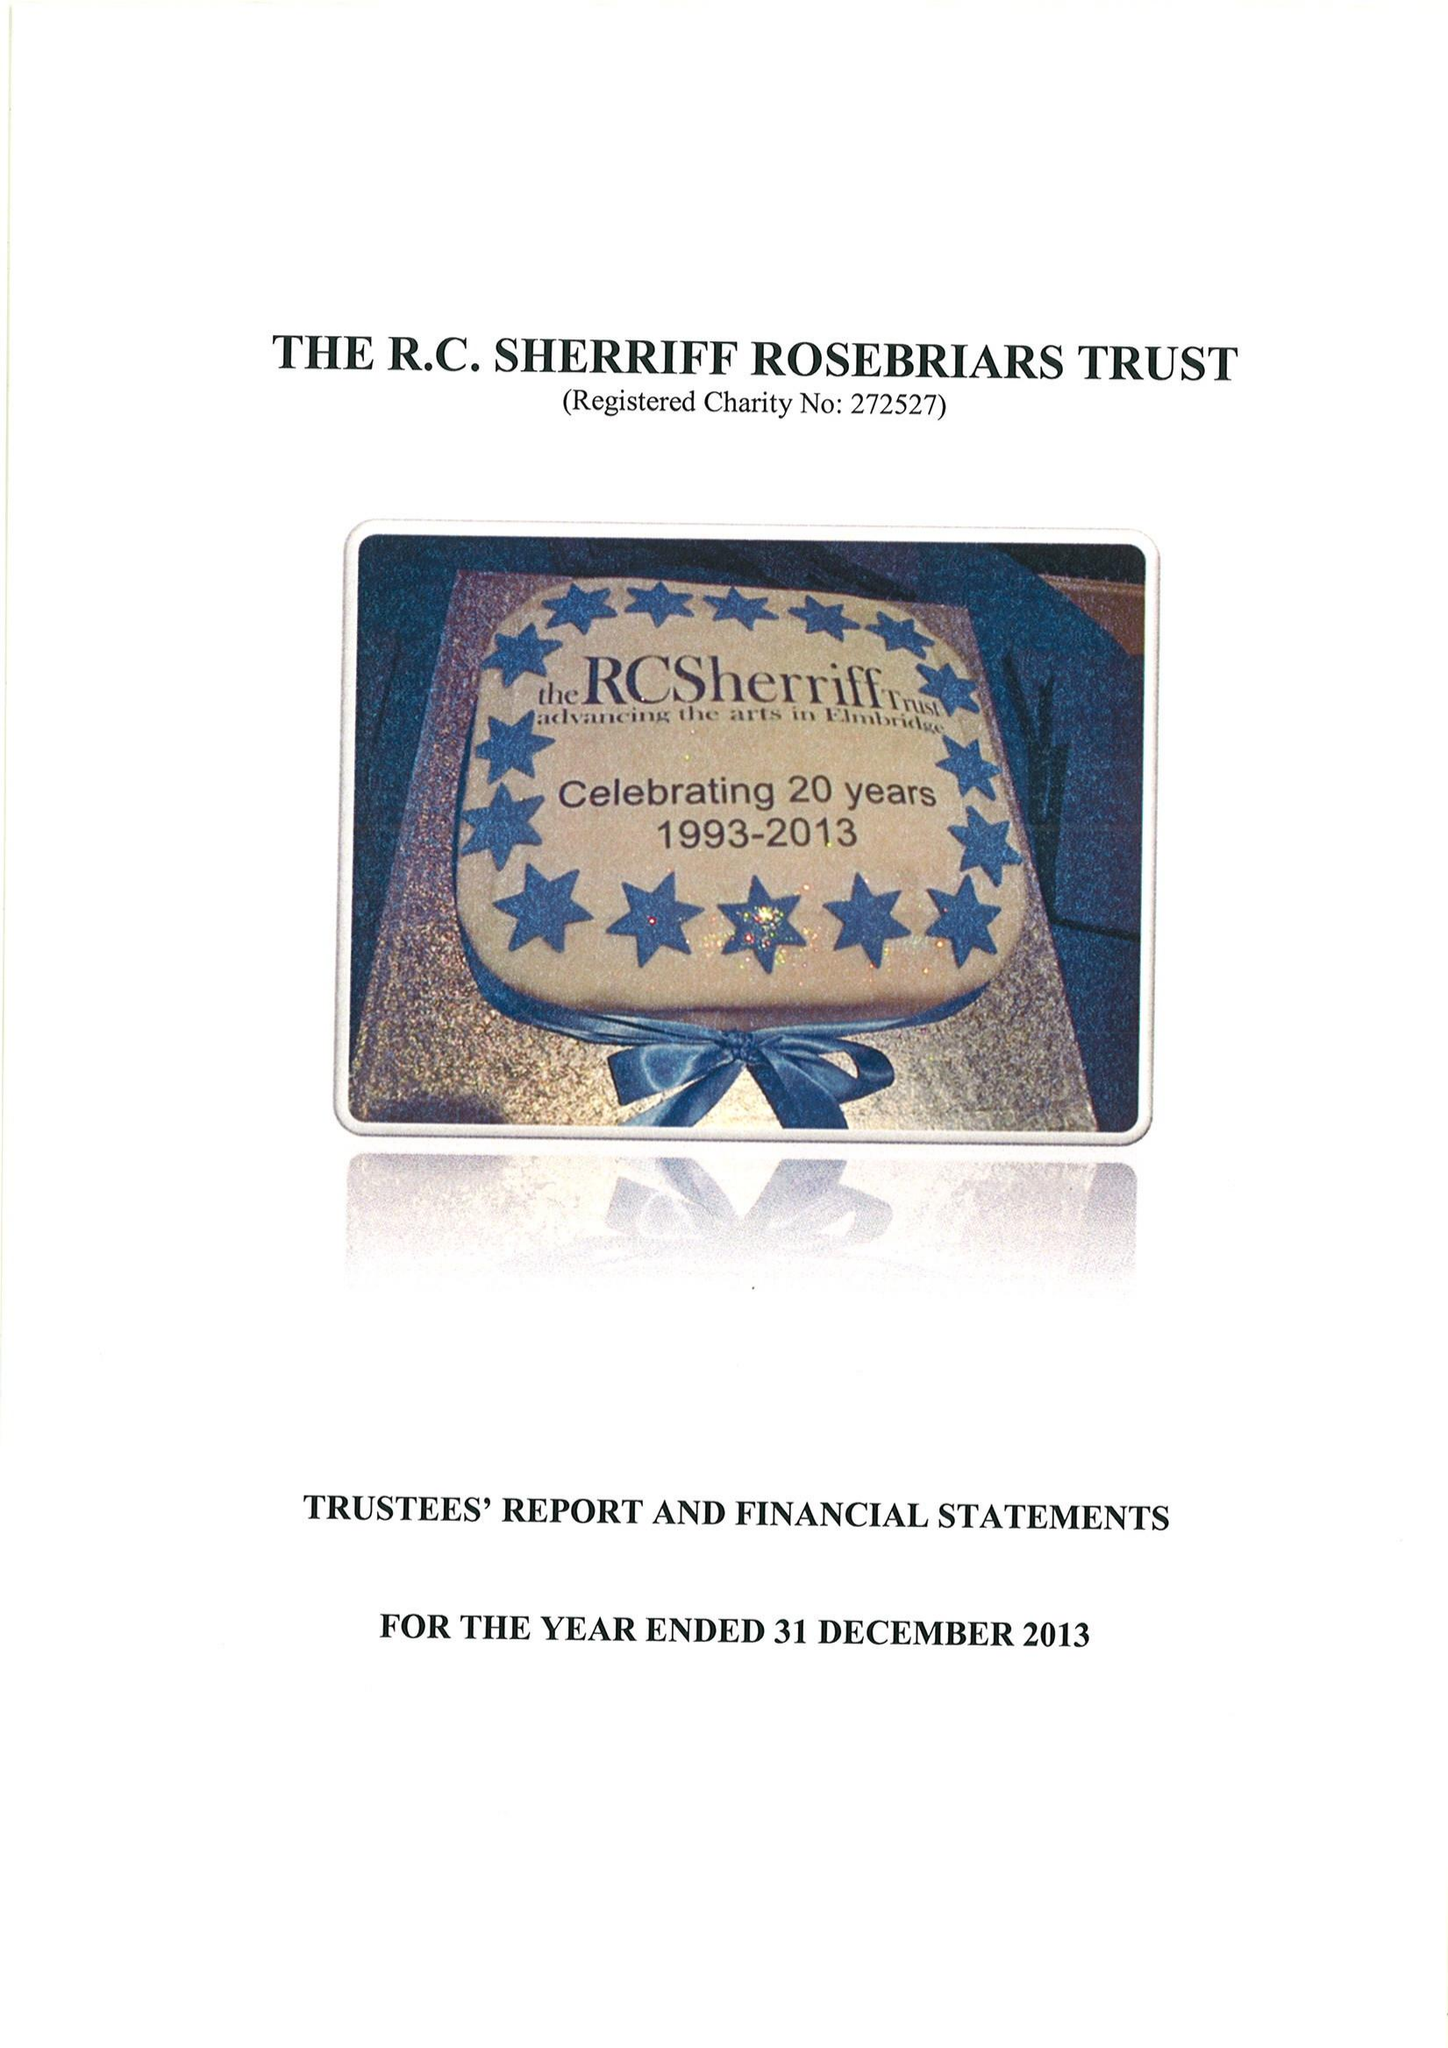What is the value for the report_date?
Answer the question using a single word or phrase. 2013-12-31 